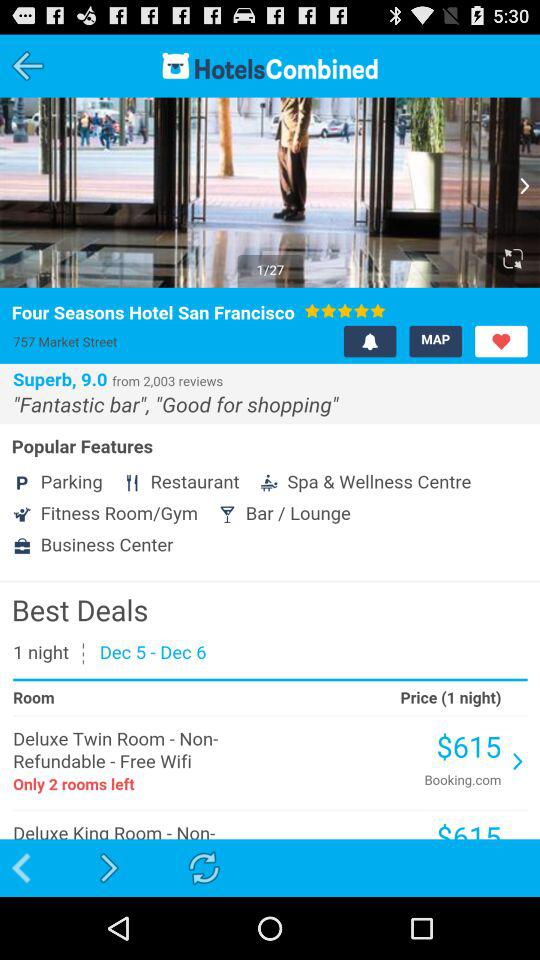What is the price of a" Deluxe Twin Room" for 1 night? The price is $615. 